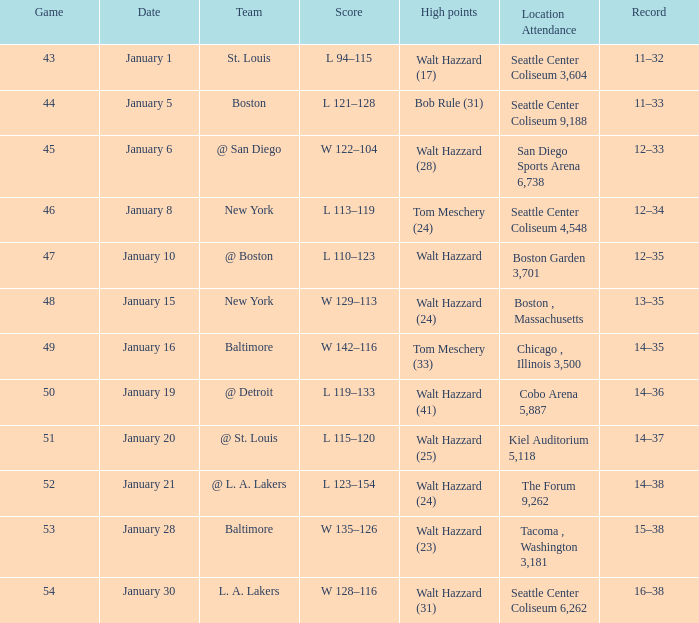What is the record for the St. Louis team? 11–32. 